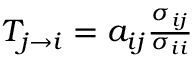Convert formula to latex. <formula><loc_0><loc_0><loc_500><loc_500>\begin{array} { r } { T _ { j \to i } = a _ { i j } \frac { \sigma _ { i j } } { \sigma _ { i i } } } \end{array}</formula> 